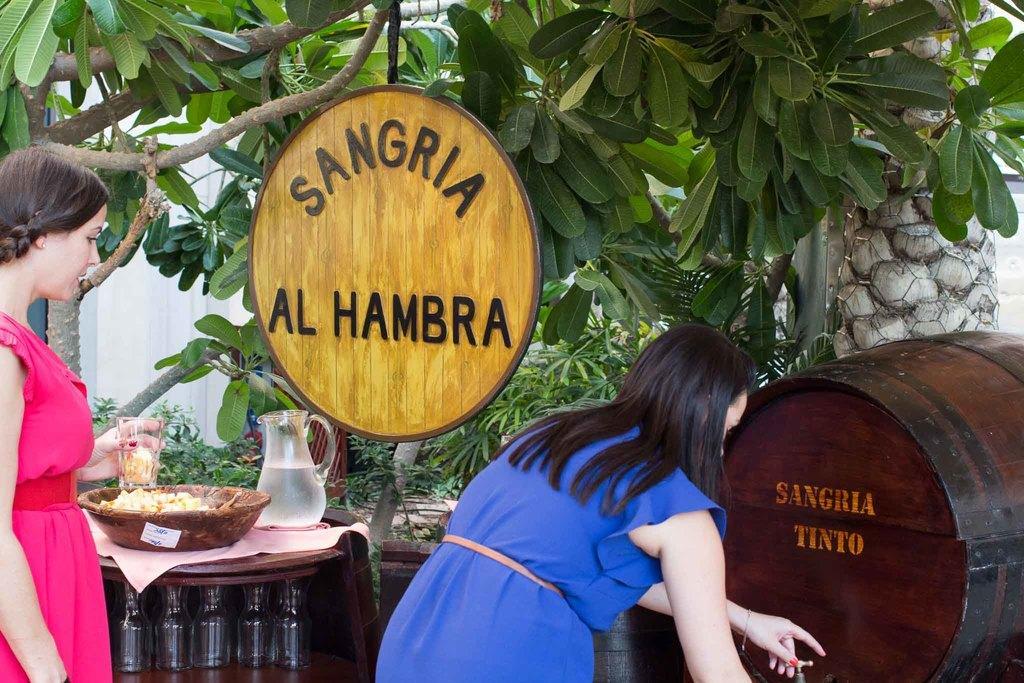Could you give a brief overview of what you see in this image? In this picture this is a woman standing holding a wine glass in her left hand, there is another woman who is feeling something and hand is on the tap. In the backdrop they are plants and a board. 